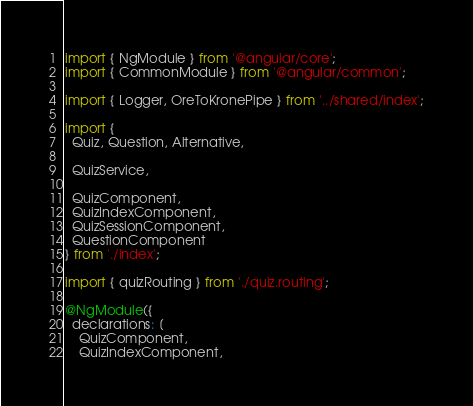Convert code to text. <code><loc_0><loc_0><loc_500><loc_500><_TypeScript_>import { NgModule } from '@angular/core';
import { CommonModule } from '@angular/common';

import { Logger, OreToKronePipe } from '../shared/index';

import {
  Quiz, Question, Alternative,

  QuizService,

  QuizComponent,
  QuizIndexComponent,
  QuizSessionComponent,
  QuestionComponent
} from './index';

import { quizRouting } from './quiz.routing';

@NgModule({
  declarations: [
    QuizComponent,
    QuizIndexComponent,</code> 